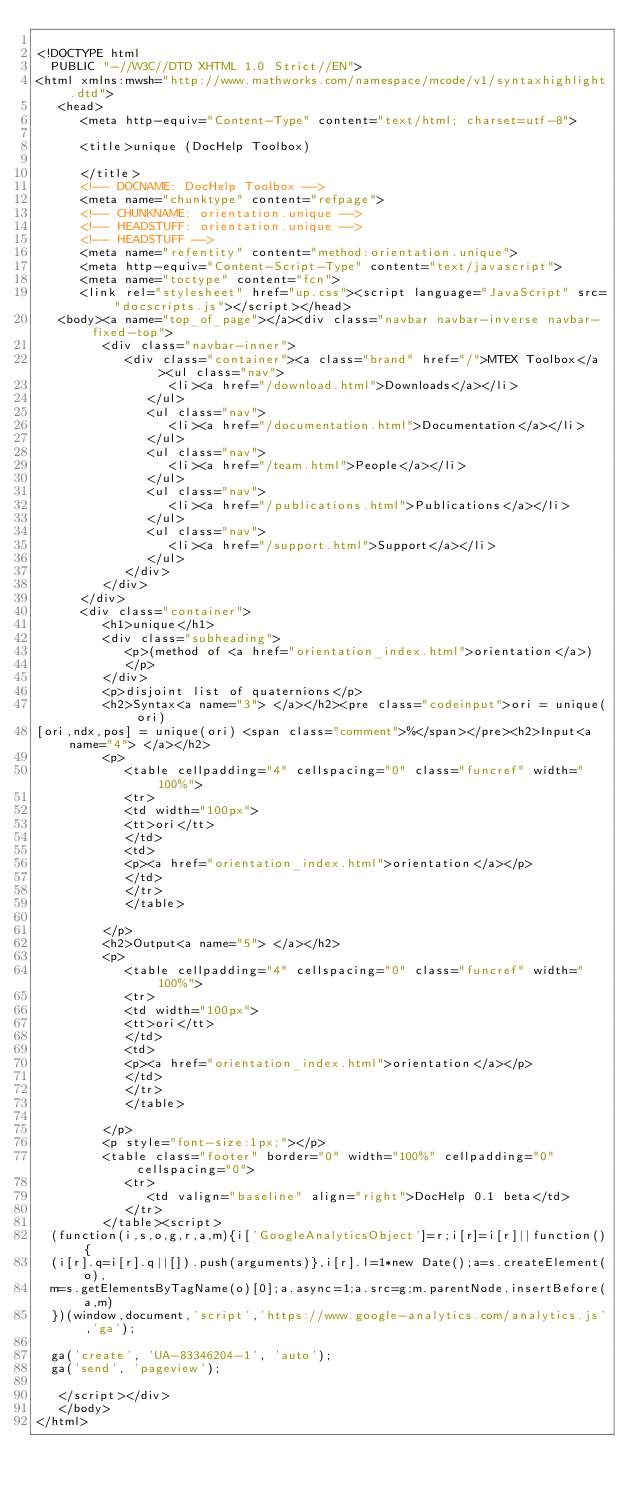Convert code to text. <code><loc_0><loc_0><loc_500><loc_500><_HTML_>
<!DOCTYPE html
  PUBLIC "-//W3C//DTD XHTML 1.0 Strict//EN">
<html xmlns:mwsh="http://www.mathworks.com/namespace/mcode/v1/syntaxhighlight.dtd">
   <head>
      <meta http-equiv="Content-Type" content="text/html; charset=utf-8">
   
      <title>unique (DocHelp Toolbox)
         
      </title>
      <!-- DOCNAME: DocHelp Toolbox -->
      <meta name="chunktype" content="refpage">
      <!-- CHUNKNAME: orientation.unique -->
      <!-- HEADSTUFF: orientation.unique -->
      <!-- HEADSTUFF -->
      <meta name="refentity" content="method:orientation.unique">
      <meta http-equiv="Content-Script-Type" content="text/javascript">
      <meta name="toctype" content="fcn">
      <link rel="stylesheet" href="up.css"><script language="JavaScript" src="docscripts.js"></script></head>
   <body><a name="top_of_page"></a><div class="navbar navbar-inverse navbar-fixed-top">
         <div class="navbar-inner">
            <div class="container"><a class="brand" href="/">MTEX Toolbox</a><ul class="nav">
                  <li><a href="/download.html">Downloads</a></li>
               </ul>
               <ul class="nav">
                  <li><a href="/documentation.html">Documentation</a></li>
               </ul>
               <ul class="nav">
                  <li><a href="/team.html">People</a></li>
               </ul>
               <ul class="nav">
                  <li><a href="/publications.html">Publications</a></li>
               </ul>
               <ul class="nav">
                  <li><a href="/support.html">Support</a></li>
               </ul>
            </div>
         </div>
      </div>
      <div class="container">
         <h1>unique</h1>
         <div class="subheading">
            <p>(method of <a href="orientation_index.html">orientation</a>)
            </p>
         </div>
         <p>disjoint list of quaternions</p>
         <h2>Syntax<a name="3"> </a></h2><pre class="codeinput">ori = unique(ori)
[ori,ndx,pos] = unique(ori) <span class="comment">%</span></pre><h2>Input<a name="4"> </a></h2>
         <p>
            <table cellpadding="4" cellspacing="0" class="funcref" width="100%">
            <tr>
            <td width="100px">
            <tt>ori</tt>
            </td>
            <td>
            <p><a href="orientation_index.html">orientation</a></p>
            </td>
            </tr>
            </table>
            
         </p>
         <h2>Output<a name="5"> </a></h2>
         <p>
            <table cellpadding="4" cellspacing="0" class="funcref" width="100%">
            <tr>
            <td width="100px">
            <tt>ori</tt>
            </td>
            <td>
            <p><a href="orientation_index.html">orientation</a></p>
            </td>
            </tr>
            </table>
            
         </p>
         <p style="font-size:1px;"></p>
         <table class="footer" border="0" width="100%" cellpadding="0" cellspacing="0">
            <tr>
               <td valign="baseline" align="right">DocHelp 0.1 beta</td>
            </tr>
         </table><script>
  (function(i,s,o,g,r,a,m){i['GoogleAnalyticsObject']=r;i[r]=i[r]||function(){
  (i[r].q=i[r].q||[]).push(arguments)},i[r].l=1*new Date();a=s.createElement(o),
  m=s.getElementsByTagName(o)[0];a.async=1;a.src=g;m.parentNode.insertBefore(a,m)
  })(window,document,'script','https://www.google-analytics.com/analytics.js','ga');

  ga('create', 'UA-83346204-1', 'auto');
  ga('send', 'pageview');

   </script></div>
   </body>
</html></code> 